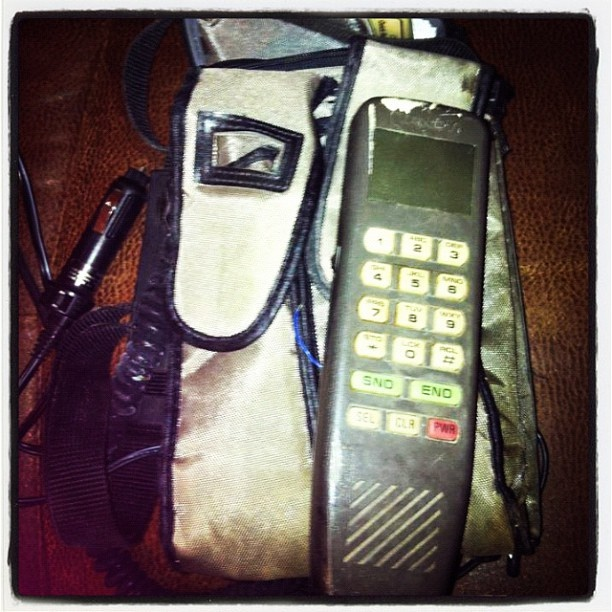Describe the objects in this image and their specific colors. I can see a handbag in white, black, beige, gray, and darkgray tones in this image. 